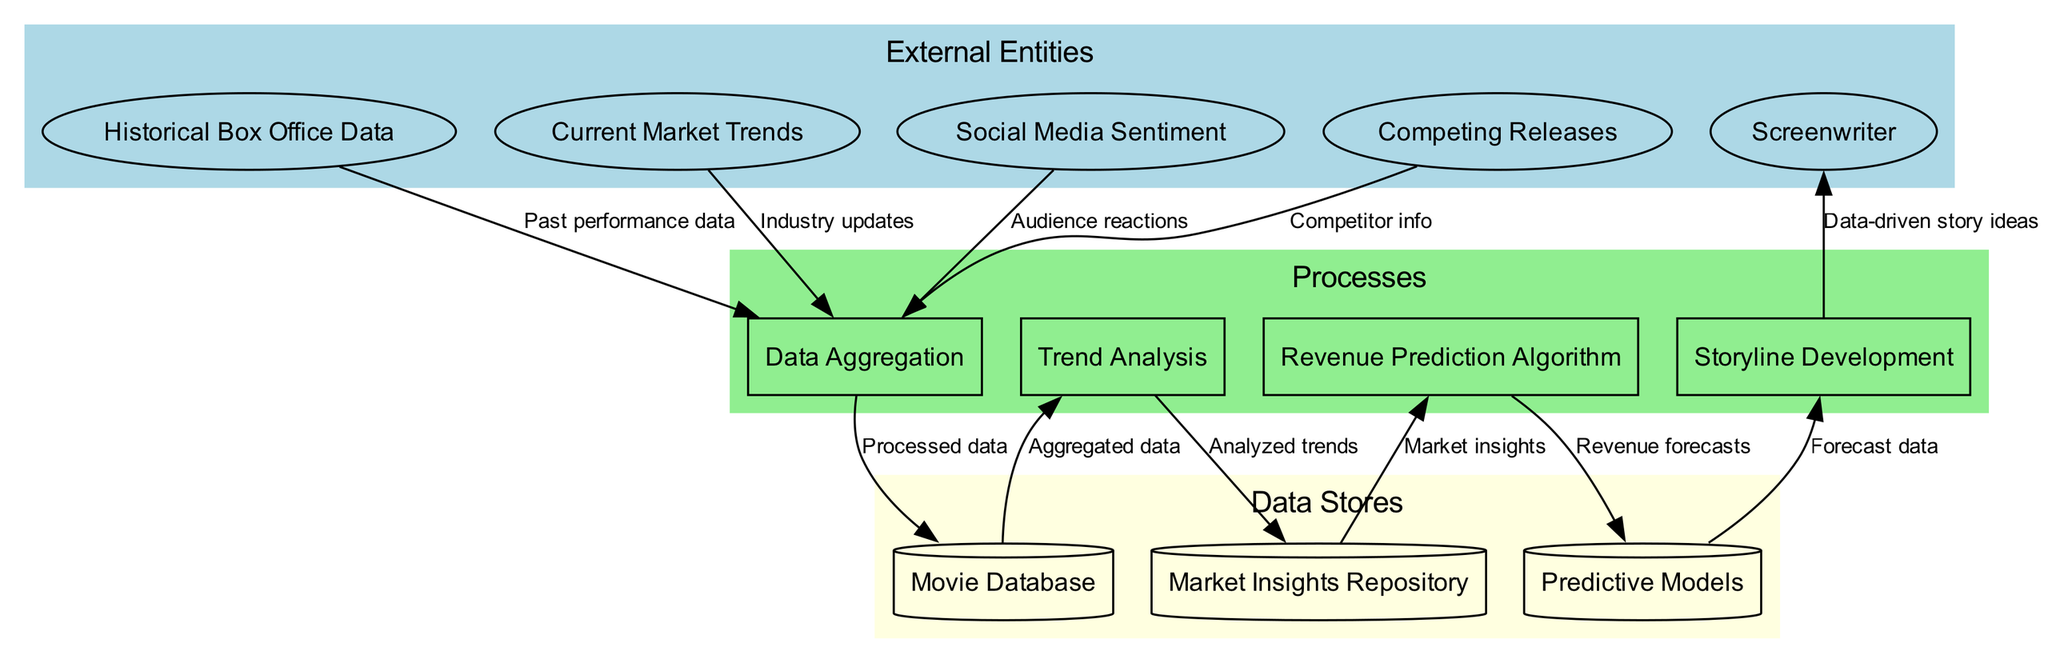What are the external entities in the diagram? The external entities section of the diagram lists the elements that provide data to the system. These are "Historical Box Office Data," "Current Market Trends," "Social Media Sentiment," "Competing Releases," and "Screenwriter."
Answer: Historical Box Office Data, Current Market Trends, Social Media Sentiment, Competing Releases, Screenwriter How many processes are represented in the diagram? The processes section includes four distinct processes: "Data Aggregation," "Trend Analysis," "Revenue Prediction Algorithm," and "Storyline Development." Therefore, there are four processes in total.
Answer: 4 What type of data flows from "Current Market Trends" to "Data Aggregation"? The data flowing from "Current Market Trends" to "Data Aggregation" is labeled "Industry updates," which indicates that this data informs the aggregation process.
Answer: Industry updates Which process receives data from the "Market Insights Repository"? The "Revenue Prediction Algorithm" is the process that receives data from the "Market Insights Repository." The flow is indicated in the diagram connecting these two nodes.
Answer: Revenue Prediction Algorithm What is the relationship between "Predictive Models" and "Storyline Development"? The "Predictive Models" provide "Forecast data" to the "Storyline Development" process, indicating that the output from the predictive models influences the storyline creation based on forecast data.
Answer: Forecast data How many external entities are integrated into the data aggregation process? The data aggregation process receives inputs from four distinct external entities: "Historical Box Office Data," "Current Market Trends," "Social Media Sentiment," and "Competing Releases." Thus, there are four external entities integrated into this process.
Answer: 4 What type of data is stored in the "Movie Database"? The "Movie Database" stores "Processed data," which is the output from the "Data Aggregation" process. This indicates that the database holds the information that has been aggregated and processed.
Answer: Processed data Which external entity directly benefits from the output of "Storyline Development"? The "Screenwriter" is the external entity that directly benefits from the output of "Storyline Development," as it is designed to provide data-driven story ideas to assist in the writing process.
Answer: Screenwriter 